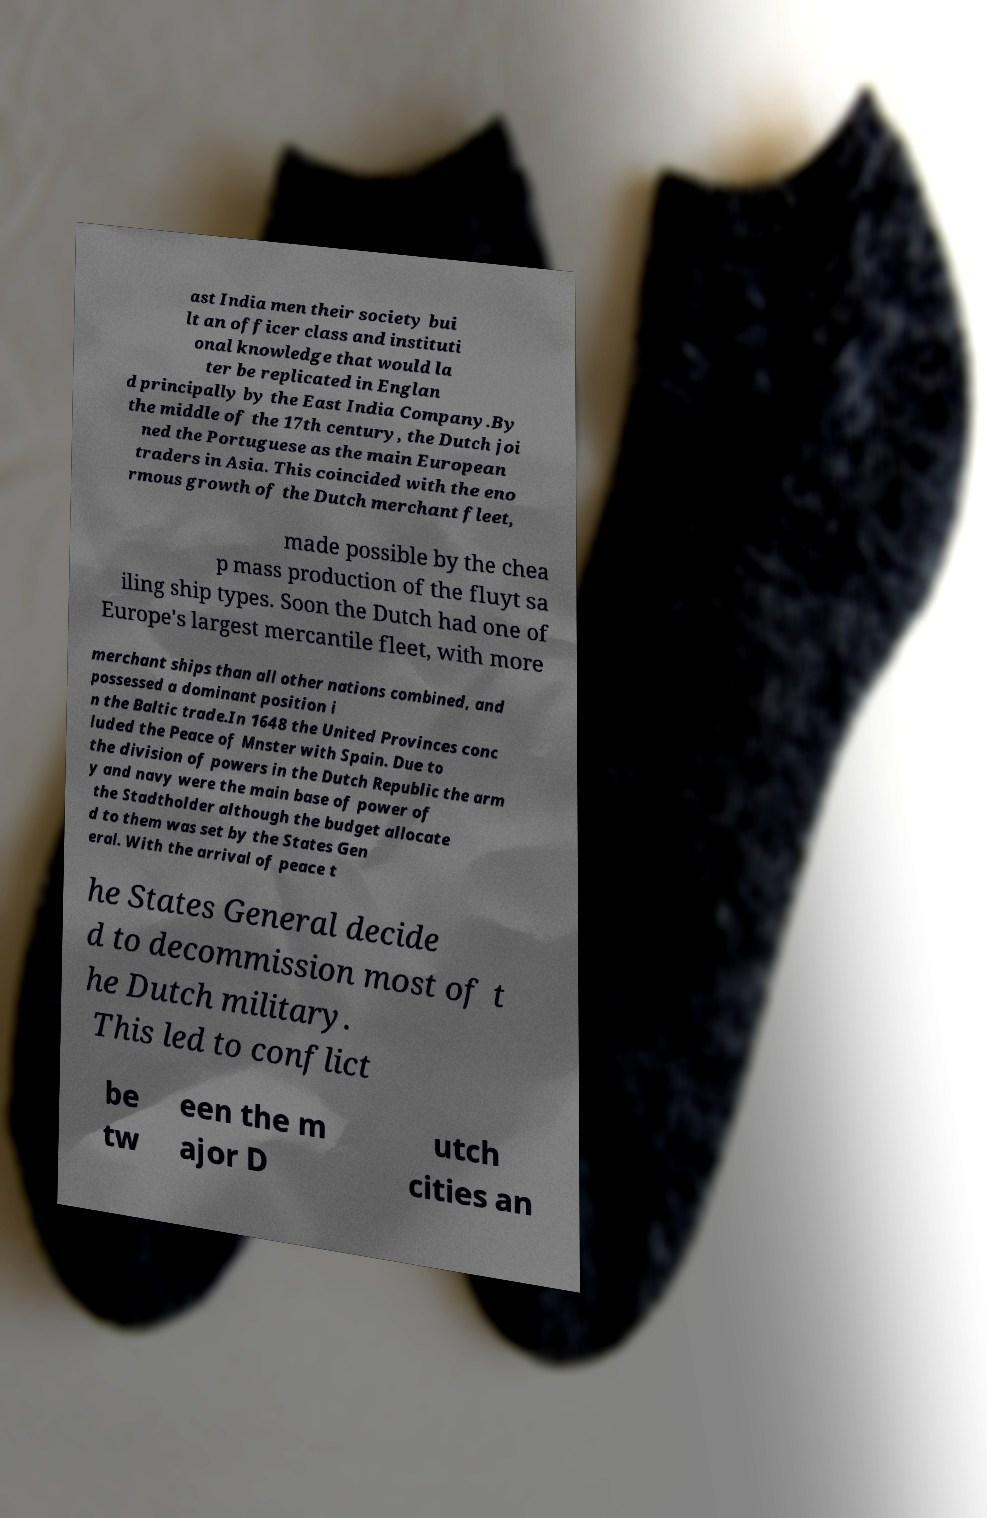Can you accurately transcribe the text from the provided image for me? ast India men their society bui lt an officer class and instituti onal knowledge that would la ter be replicated in Englan d principally by the East India Company.By the middle of the 17th century, the Dutch joi ned the Portuguese as the main European traders in Asia. This coincided with the eno rmous growth of the Dutch merchant fleet, made possible by the chea p mass production of the fluyt sa iling ship types. Soon the Dutch had one of Europe's largest mercantile fleet, with more merchant ships than all other nations combined, and possessed a dominant position i n the Baltic trade.In 1648 the United Provinces conc luded the Peace of Mnster with Spain. Due to the division of powers in the Dutch Republic the arm y and navy were the main base of power of the Stadtholder although the budget allocate d to them was set by the States Gen eral. With the arrival of peace t he States General decide d to decommission most of t he Dutch military. This led to conflict be tw een the m ajor D utch cities an 